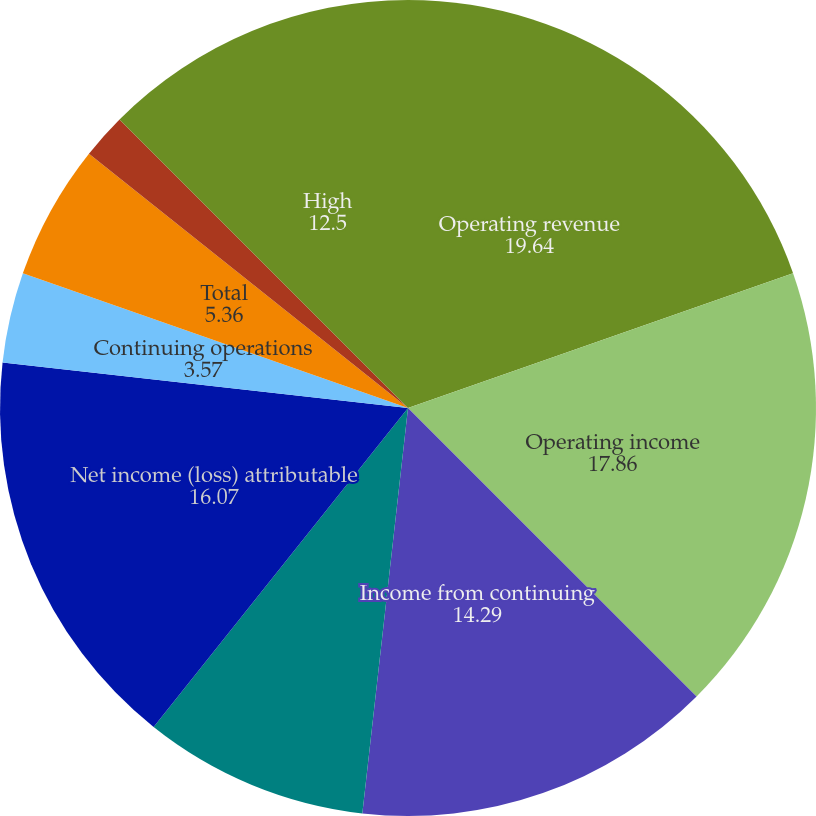<chart> <loc_0><loc_0><loc_500><loc_500><pie_chart><fcel>Operating revenue<fcel>Operating income<fcel>Income from continuing<fcel>Income (loss) from<fcel>Net income (loss) attributable<fcel>Continuing operations<fcel>Discontinued operations<fcel>Total<fcel>Dividends declared per share<fcel>High<nl><fcel>19.64%<fcel>17.86%<fcel>14.29%<fcel>8.93%<fcel>16.07%<fcel>3.57%<fcel>0.0%<fcel>5.36%<fcel>1.79%<fcel>12.5%<nl></chart> 